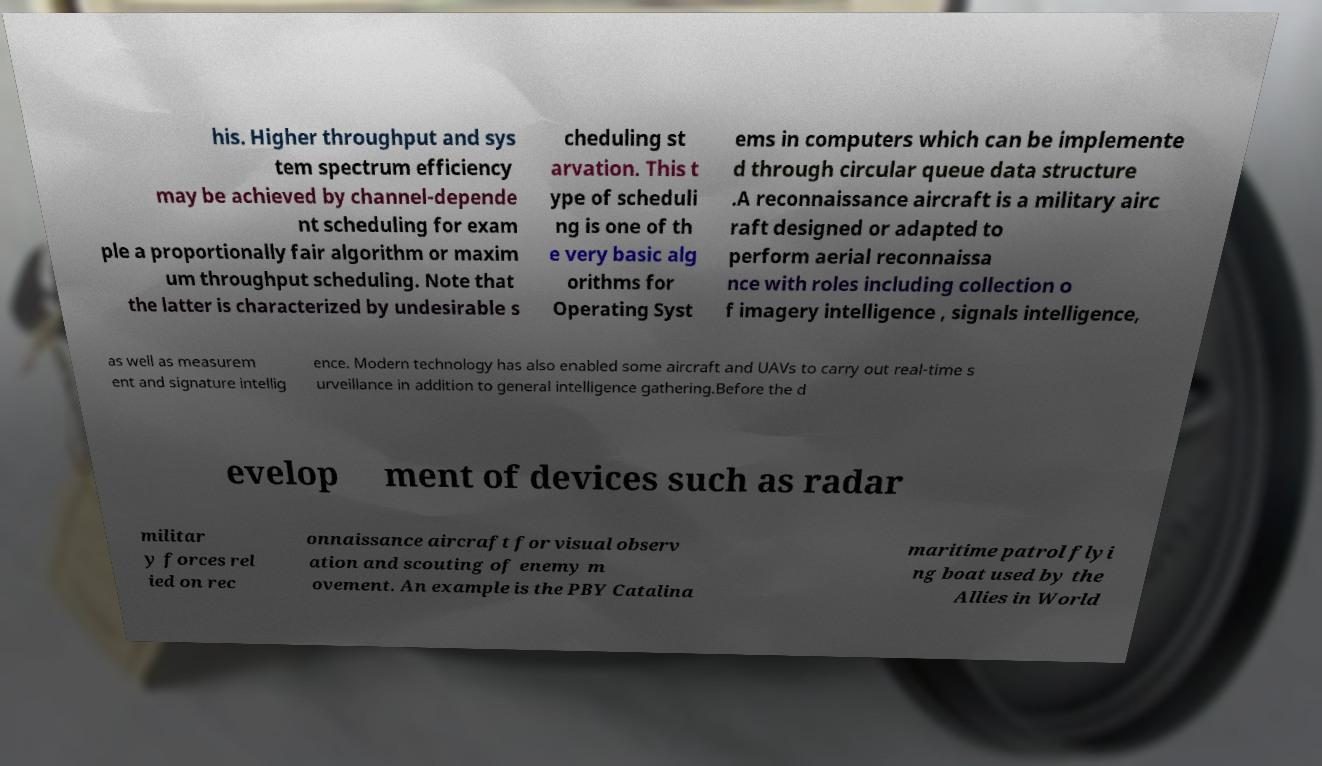For documentation purposes, I need the text within this image transcribed. Could you provide that? his. Higher throughput and sys tem spectrum efficiency may be achieved by channel-depende nt scheduling for exam ple a proportionally fair algorithm or maxim um throughput scheduling. Note that the latter is characterized by undesirable s cheduling st arvation. This t ype of scheduli ng is one of th e very basic alg orithms for Operating Syst ems in computers which can be implemente d through circular queue data structure .A reconnaissance aircraft is a military airc raft designed or adapted to perform aerial reconnaissa nce with roles including collection o f imagery intelligence , signals intelligence, as well as measurem ent and signature intellig ence. Modern technology has also enabled some aircraft and UAVs to carry out real-time s urveillance in addition to general intelligence gathering.Before the d evelop ment of devices such as radar militar y forces rel ied on rec onnaissance aircraft for visual observ ation and scouting of enemy m ovement. An example is the PBY Catalina maritime patrol flyi ng boat used by the Allies in World 